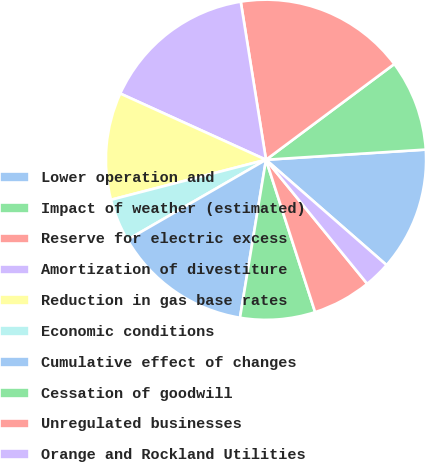Convert chart to OTSL. <chart><loc_0><loc_0><loc_500><loc_500><pie_chart><fcel>Lower operation and<fcel>Impact of weather (estimated)<fcel>Reserve for electric excess<fcel>Amortization of divestiture<fcel>Reduction in gas base rates<fcel>Economic conditions<fcel>Cumulative effect of changes<fcel>Cessation of goodwill<fcel>Unregulated businesses<fcel>Orange and Rockland Utilities<nl><fcel>12.44%<fcel>9.19%<fcel>17.32%<fcel>15.69%<fcel>10.81%<fcel>4.31%<fcel>14.07%<fcel>7.56%<fcel>5.93%<fcel>2.68%<nl></chart> 